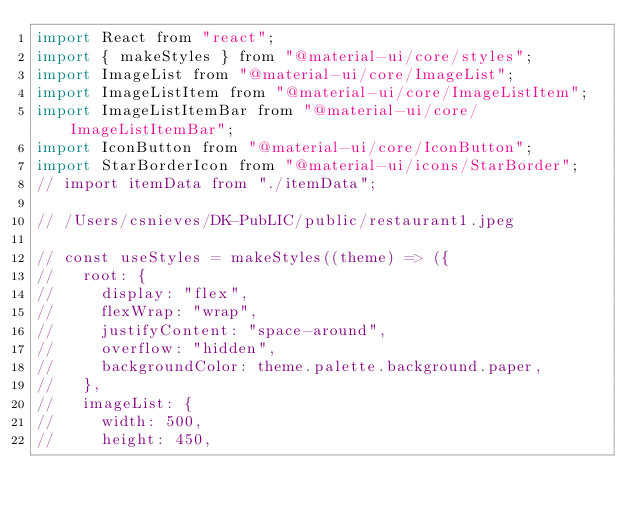<code> <loc_0><loc_0><loc_500><loc_500><_JavaScript_>import React from "react";
import { makeStyles } from "@material-ui/core/styles";
import ImageList from "@material-ui/core/ImageList";
import ImageListItem from "@material-ui/core/ImageListItem";
import ImageListItemBar from "@material-ui/core/ImageListItemBar";
import IconButton from "@material-ui/core/IconButton";
import StarBorderIcon from "@material-ui/icons/StarBorder";
// import itemData from "./itemData";

// /Users/csnieves/DK-PubLIC/public/restaurant1.jpeg

// const useStyles = makeStyles((theme) => ({
//   root: {
//     display: "flex",
//     flexWrap: "wrap",
//     justifyContent: "space-around",
//     overflow: "hidden",
//     backgroundColor: theme.palette.background.paper,
//   },
//   imageList: {
//     width: 500,
//     height: 450,</code> 